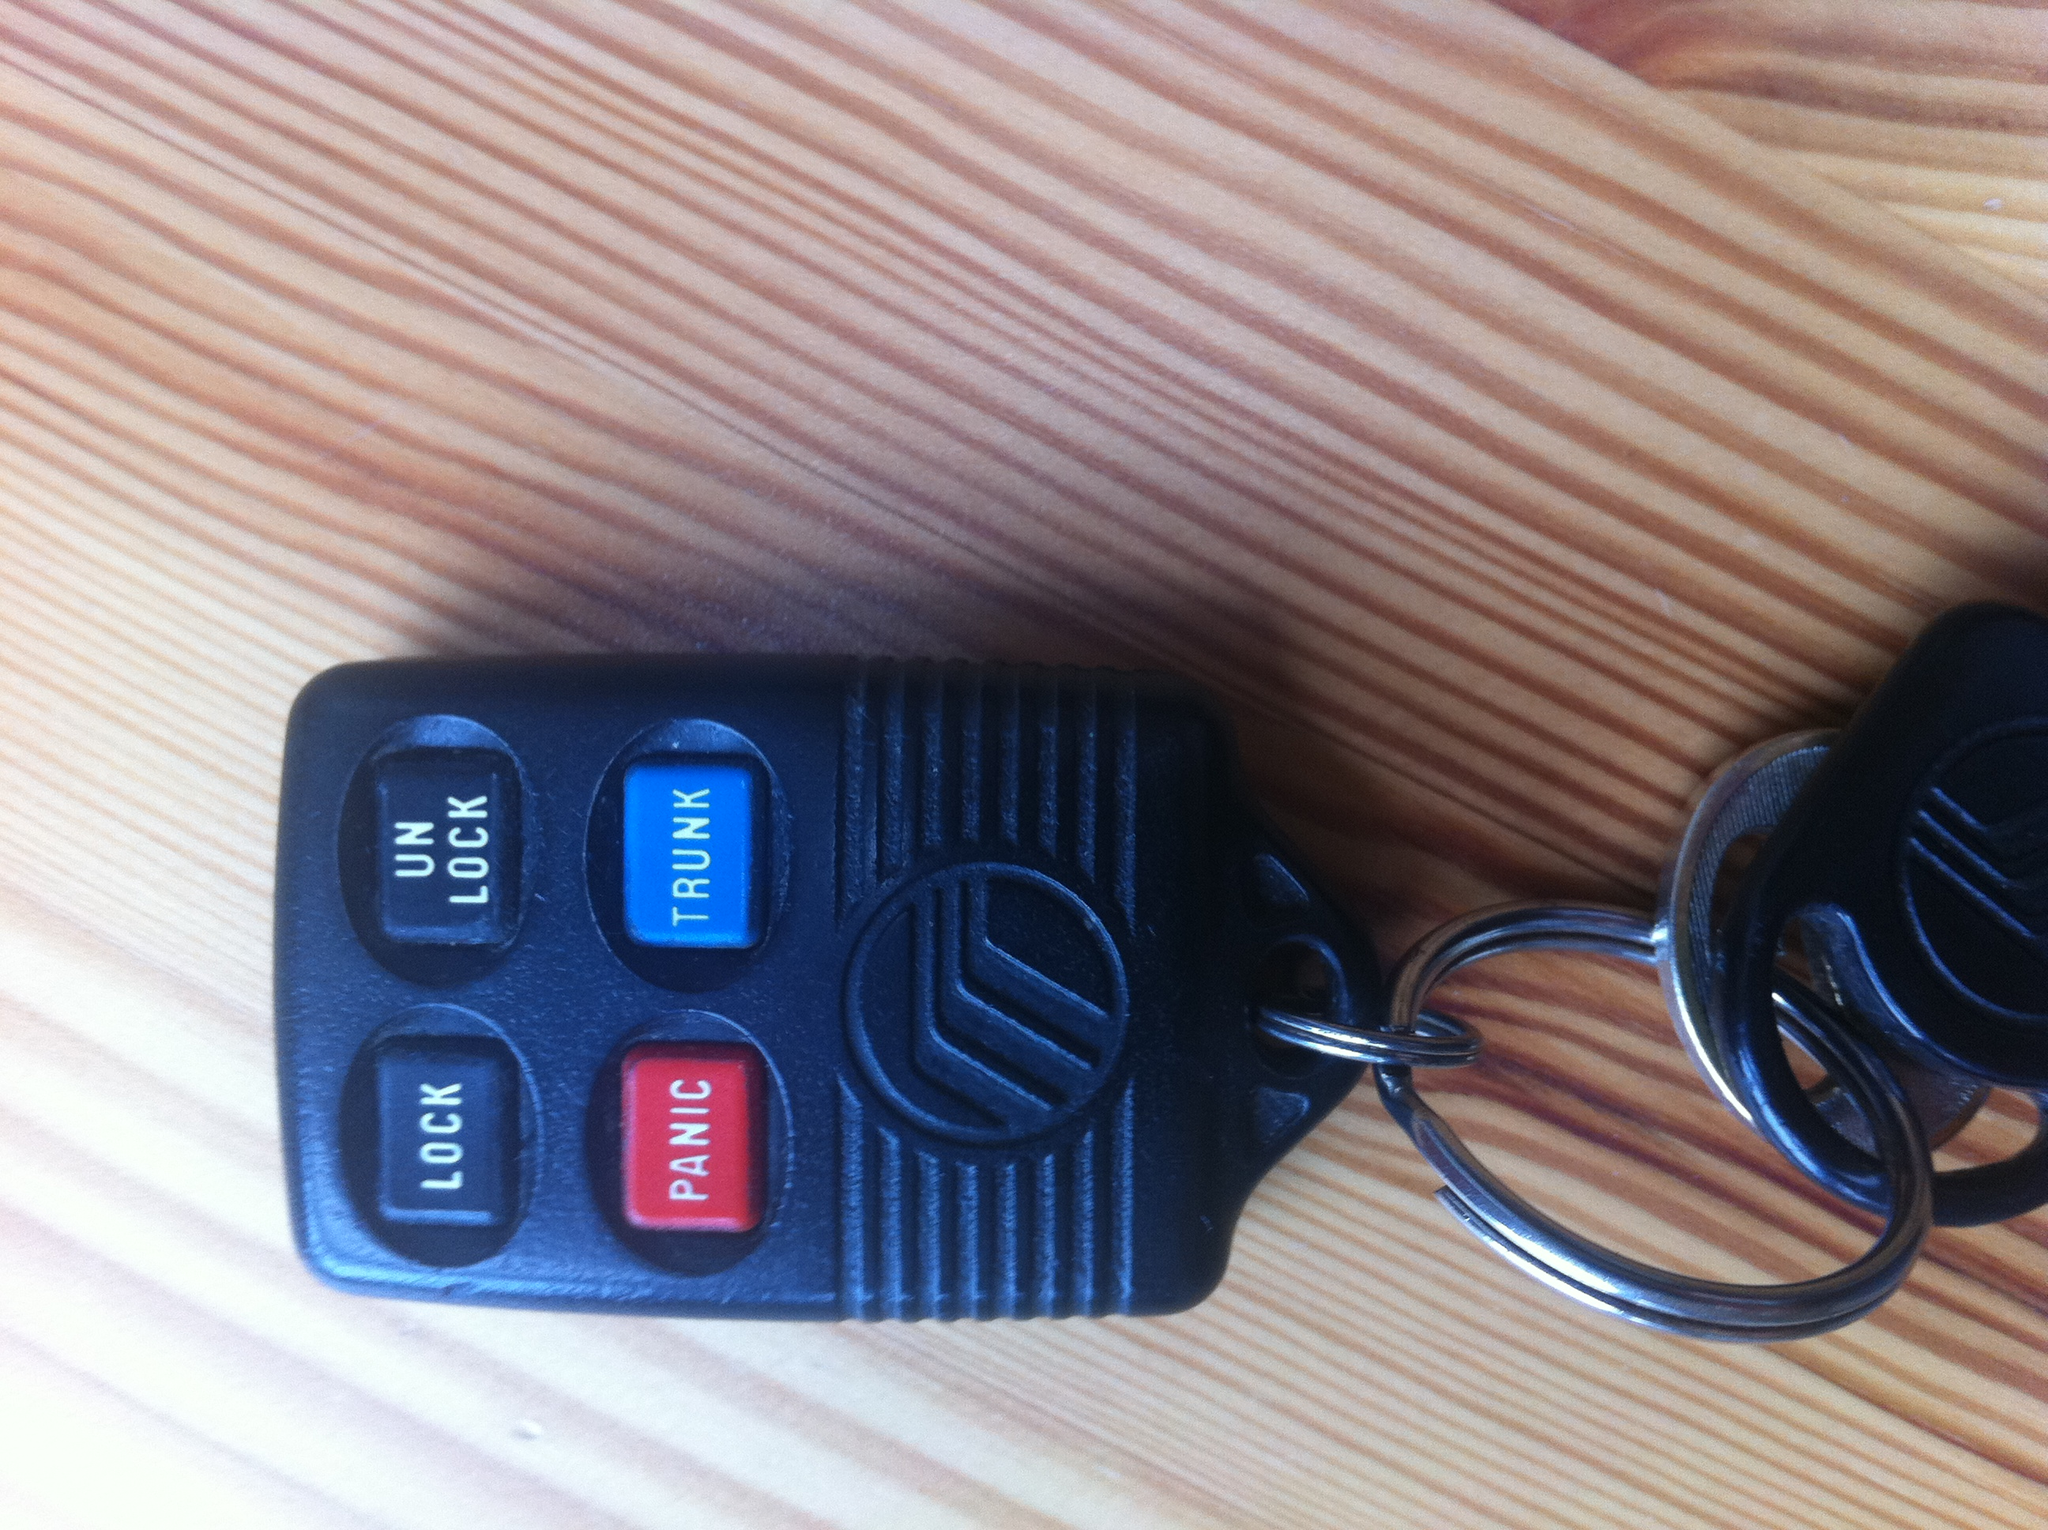Describe a realistic scenario where the 'PANIC' button could be used effectively. In a realistic scenario, the 'PANIC' button on the key fob could be used effectively in a situation where a person feels threatened in a parking lot. If an individual notices someone acting suspiciously or approaching them aggressively, they can activate the panic button to sound the vehicle's alarm. This loud sound would attract attention, potentially deterring the threat and alerting nearby people to the situation. 